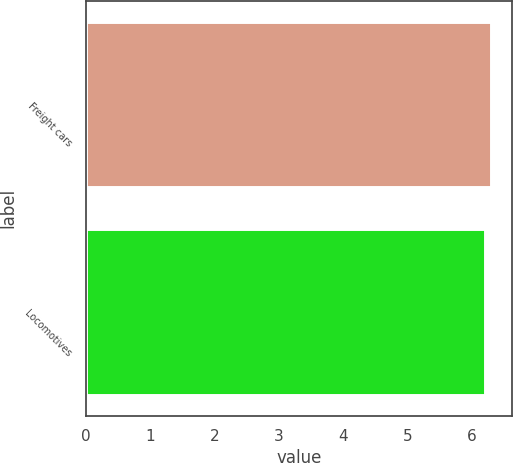<chart> <loc_0><loc_0><loc_500><loc_500><bar_chart><fcel>Freight cars<fcel>Locomotives<nl><fcel>6.3<fcel>6.2<nl></chart> 